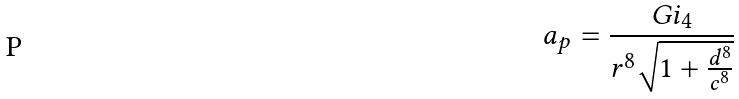<formula> <loc_0><loc_0><loc_500><loc_500>a _ { p } = \frac { G i _ { 4 } } { r ^ { 8 } \sqrt { 1 + \frac { d ^ { 8 } } { c ^ { 8 } } } }</formula> 